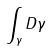Convert formula to latex. <formula><loc_0><loc_0><loc_500><loc_500>\int _ { \gamma } D \gamma</formula> 